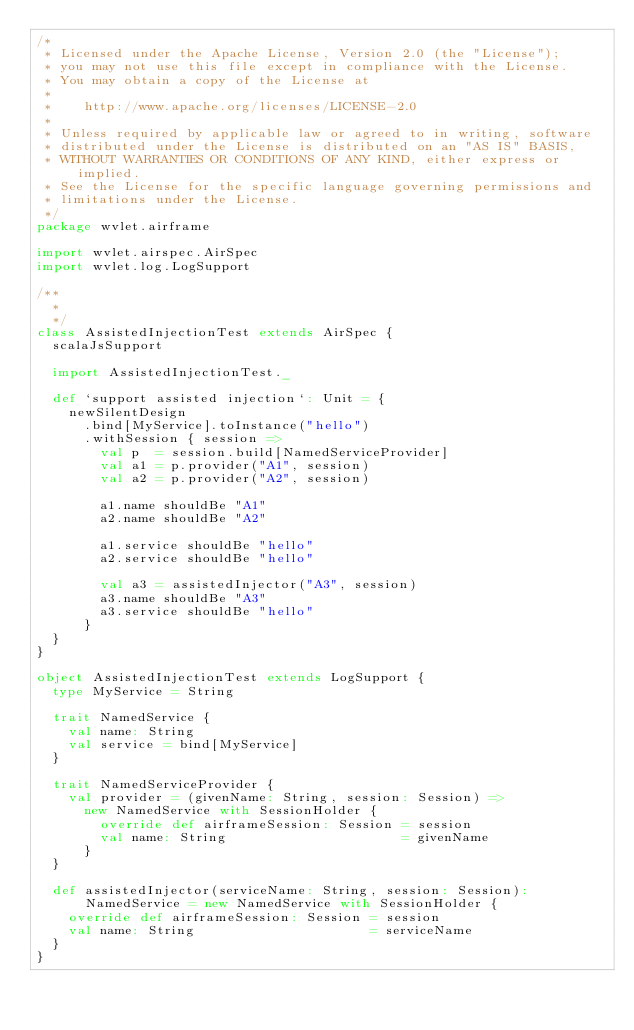<code> <loc_0><loc_0><loc_500><loc_500><_Scala_>/*
 * Licensed under the Apache License, Version 2.0 (the "License");
 * you may not use this file except in compliance with the License.
 * You may obtain a copy of the License at
 *
 *    http://www.apache.org/licenses/LICENSE-2.0
 *
 * Unless required by applicable law or agreed to in writing, software
 * distributed under the License is distributed on an "AS IS" BASIS,
 * WITHOUT WARRANTIES OR CONDITIONS OF ANY KIND, either express or implied.
 * See the License for the specific language governing permissions and
 * limitations under the License.
 */
package wvlet.airframe

import wvlet.airspec.AirSpec
import wvlet.log.LogSupport

/**
  *
  */
class AssistedInjectionTest extends AirSpec {
  scalaJsSupport

  import AssistedInjectionTest._

  def `support assisted injection`: Unit = {
    newSilentDesign
      .bind[MyService].toInstance("hello")
      .withSession { session =>
        val p  = session.build[NamedServiceProvider]
        val a1 = p.provider("A1", session)
        val a2 = p.provider("A2", session)

        a1.name shouldBe "A1"
        a2.name shouldBe "A2"

        a1.service shouldBe "hello"
        a2.service shouldBe "hello"

        val a3 = assistedInjector("A3", session)
        a3.name shouldBe "A3"
        a3.service shouldBe "hello"
      }
  }
}

object AssistedInjectionTest extends LogSupport {
  type MyService = String

  trait NamedService {
    val name: String
    val service = bind[MyService]
  }

  trait NamedServiceProvider {
    val provider = (givenName: String, session: Session) =>
      new NamedService with SessionHolder {
        override def airframeSession: Session = session
        val name: String                      = givenName
      }
  }

  def assistedInjector(serviceName: String, session: Session): NamedService = new NamedService with SessionHolder {
    override def airframeSession: Session = session
    val name: String                      = serviceName
  }
}
</code> 